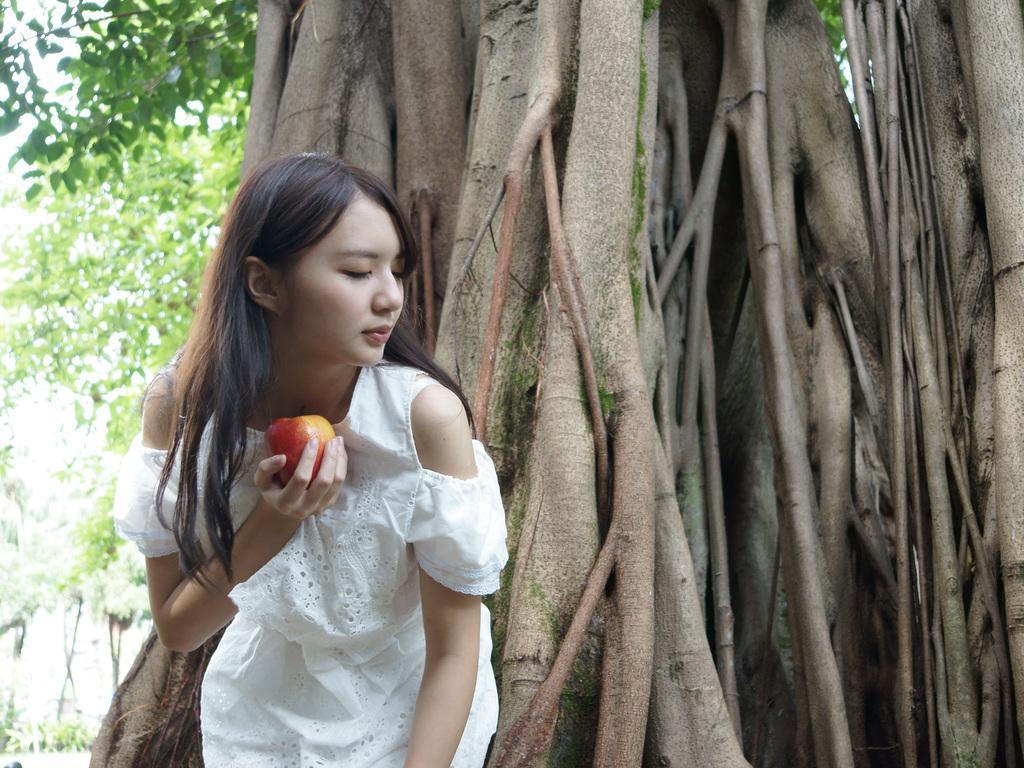In one or two sentences, can you explain what this image depicts? This is the woman standing and holding an apple. This looks like a tree trunk. On the left side of the image, I can see the trees. 